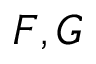<formula> <loc_0><loc_0><loc_500><loc_500>F , G</formula> 